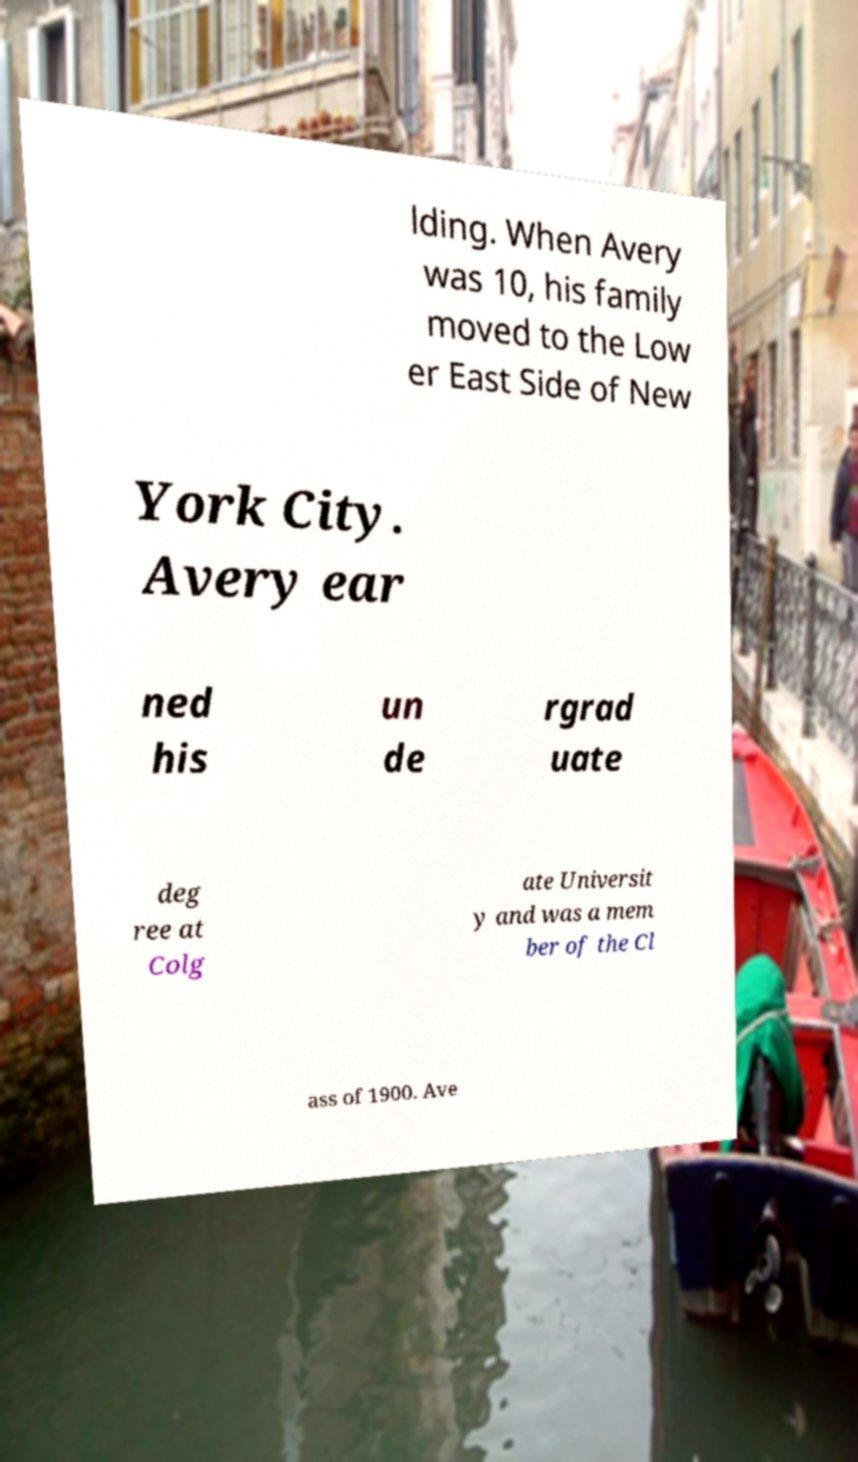Can you accurately transcribe the text from the provided image for me? lding. When Avery was 10, his family moved to the Low er East Side of New York City. Avery ear ned his un de rgrad uate deg ree at Colg ate Universit y and was a mem ber of the Cl ass of 1900. Ave 